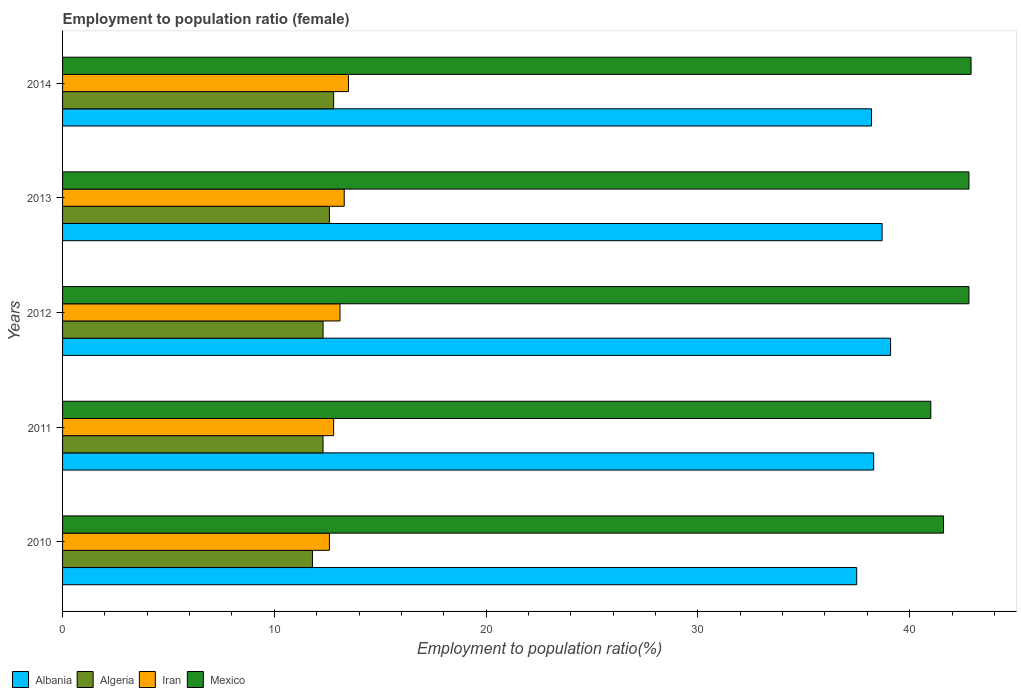How many groups of bars are there?
Give a very brief answer. 5. Are the number of bars per tick equal to the number of legend labels?
Offer a very short reply. Yes. What is the employment to population ratio in Mexico in 2010?
Provide a short and direct response. 41.6. Across all years, what is the maximum employment to population ratio in Algeria?
Your answer should be very brief. 12.8. Across all years, what is the minimum employment to population ratio in Algeria?
Provide a short and direct response. 11.8. What is the total employment to population ratio in Iran in the graph?
Provide a succinct answer. 65.3. What is the difference between the employment to population ratio in Algeria in 2012 and that in 2013?
Make the answer very short. -0.3. What is the difference between the employment to population ratio in Iran in 2011 and the employment to population ratio in Mexico in 2013?
Ensure brevity in your answer.  -30. What is the average employment to population ratio in Albania per year?
Keep it short and to the point. 38.36. In the year 2011, what is the difference between the employment to population ratio in Mexico and employment to population ratio in Algeria?
Offer a terse response. 28.7. What is the ratio of the employment to population ratio in Mexico in 2013 to that in 2014?
Make the answer very short. 1. Is the employment to population ratio in Albania in 2011 less than that in 2014?
Offer a terse response. No. Is the difference between the employment to population ratio in Mexico in 2011 and 2014 greater than the difference between the employment to population ratio in Algeria in 2011 and 2014?
Your answer should be compact. No. What is the difference between the highest and the second highest employment to population ratio in Albania?
Your answer should be compact. 0.4. In how many years, is the employment to population ratio in Albania greater than the average employment to population ratio in Albania taken over all years?
Your answer should be very brief. 2. What does the 4th bar from the top in 2014 represents?
Your response must be concise. Albania. What does the 2nd bar from the bottom in 2011 represents?
Your answer should be very brief. Algeria. What is the difference between two consecutive major ticks on the X-axis?
Provide a succinct answer. 10. Are the values on the major ticks of X-axis written in scientific E-notation?
Offer a terse response. No. Does the graph contain any zero values?
Keep it short and to the point. No. Does the graph contain grids?
Provide a short and direct response. No. Where does the legend appear in the graph?
Offer a very short reply. Bottom left. What is the title of the graph?
Give a very brief answer. Employment to population ratio (female). Does "Belarus" appear as one of the legend labels in the graph?
Your response must be concise. No. What is the label or title of the Y-axis?
Your answer should be very brief. Years. What is the Employment to population ratio(%) in Albania in 2010?
Your answer should be very brief. 37.5. What is the Employment to population ratio(%) of Algeria in 2010?
Provide a succinct answer. 11.8. What is the Employment to population ratio(%) in Iran in 2010?
Provide a succinct answer. 12.6. What is the Employment to population ratio(%) of Mexico in 2010?
Your answer should be very brief. 41.6. What is the Employment to population ratio(%) in Albania in 2011?
Provide a short and direct response. 38.3. What is the Employment to population ratio(%) of Algeria in 2011?
Provide a short and direct response. 12.3. What is the Employment to population ratio(%) of Iran in 2011?
Your answer should be very brief. 12.8. What is the Employment to population ratio(%) in Mexico in 2011?
Give a very brief answer. 41. What is the Employment to population ratio(%) in Albania in 2012?
Your answer should be very brief. 39.1. What is the Employment to population ratio(%) of Algeria in 2012?
Your answer should be very brief. 12.3. What is the Employment to population ratio(%) of Iran in 2012?
Your answer should be compact. 13.1. What is the Employment to population ratio(%) in Mexico in 2012?
Keep it short and to the point. 42.8. What is the Employment to population ratio(%) of Albania in 2013?
Offer a terse response. 38.7. What is the Employment to population ratio(%) of Algeria in 2013?
Make the answer very short. 12.6. What is the Employment to population ratio(%) in Iran in 2013?
Your answer should be compact. 13.3. What is the Employment to population ratio(%) in Mexico in 2013?
Provide a succinct answer. 42.8. What is the Employment to population ratio(%) in Albania in 2014?
Give a very brief answer. 38.2. What is the Employment to population ratio(%) in Algeria in 2014?
Make the answer very short. 12.8. What is the Employment to population ratio(%) in Mexico in 2014?
Provide a succinct answer. 42.9. Across all years, what is the maximum Employment to population ratio(%) in Albania?
Provide a succinct answer. 39.1. Across all years, what is the maximum Employment to population ratio(%) of Algeria?
Give a very brief answer. 12.8. Across all years, what is the maximum Employment to population ratio(%) in Mexico?
Offer a very short reply. 42.9. Across all years, what is the minimum Employment to population ratio(%) of Albania?
Provide a succinct answer. 37.5. Across all years, what is the minimum Employment to population ratio(%) in Algeria?
Ensure brevity in your answer.  11.8. Across all years, what is the minimum Employment to population ratio(%) of Iran?
Your answer should be very brief. 12.6. What is the total Employment to population ratio(%) of Albania in the graph?
Provide a succinct answer. 191.8. What is the total Employment to population ratio(%) in Algeria in the graph?
Ensure brevity in your answer.  61.8. What is the total Employment to population ratio(%) in Iran in the graph?
Provide a succinct answer. 65.3. What is the total Employment to population ratio(%) of Mexico in the graph?
Give a very brief answer. 211.1. What is the difference between the Employment to population ratio(%) in Albania in 2010 and that in 2011?
Your response must be concise. -0.8. What is the difference between the Employment to population ratio(%) of Algeria in 2010 and that in 2011?
Offer a terse response. -0.5. What is the difference between the Employment to population ratio(%) in Iran in 2010 and that in 2011?
Provide a succinct answer. -0.2. What is the difference between the Employment to population ratio(%) in Albania in 2010 and that in 2012?
Keep it short and to the point. -1.6. What is the difference between the Employment to population ratio(%) of Iran in 2010 and that in 2012?
Provide a succinct answer. -0.5. What is the difference between the Employment to population ratio(%) of Mexico in 2010 and that in 2012?
Offer a very short reply. -1.2. What is the difference between the Employment to population ratio(%) in Albania in 2010 and that in 2013?
Your answer should be compact. -1.2. What is the difference between the Employment to population ratio(%) of Iran in 2010 and that in 2013?
Offer a very short reply. -0.7. What is the difference between the Employment to population ratio(%) in Mexico in 2010 and that in 2013?
Keep it short and to the point. -1.2. What is the difference between the Employment to population ratio(%) in Iran in 2010 and that in 2014?
Offer a terse response. -0.9. What is the difference between the Employment to population ratio(%) of Algeria in 2011 and that in 2012?
Your answer should be very brief. 0. What is the difference between the Employment to population ratio(%) in Iran in 2011 and that in 2012?
Offer a very short reply. -0.3. What is the difference between the Employment to population ratio(%) of Algeria in 2011 and that in 2013?
Keep it short and to the point. -0.3. What is the difference between the Employment to population ratio(%) in Iran in 2011 and that in 2014?
Offer a very short reply. -0.7. What is the difference between the Employment to population ratio(%) of Mexico in 2011 and that in 2014?
Provide a short and direct response. -1.9. What is the difference between the Employment to population ratio(%) in Albania in 2012 and that in 2013?
Offer a terse response. 0.4. What is the difference between the Employment to population ratio(%) in Algeria in 2012 and that in 2013?
Provide a short and direct response. -0.3. What is the difference between the Employment to population ratio(%) in Iran in 2012 and that in 2013?
Make the answer very short. -0.2. What is the difference between the Employment to population ratio(%) in Mexico in 2012 and that in 2013?
Offer a terse response. 0. What is the difference between the Employment to population ratio(%) in Algeria in 2012 and that in 2014?
Your answer should be compact. -0.5. What is the difference between the Employment to population ratio(%) of Mexico in 2012 and that in 2014?
Offer a very short reply. -0.1. What is the difference between the Employment to population ratio(%) of Albania in 2013 and that in 2014?
Give a very brief answer. 0.5. What is the difference between the Employment to population ratio(%) of Iran in 2013 and that in 2014?
Provide a short and direct response. -0.2. What is the difference between the Employment to population ratio(%) in Mexico in 2013 and that in 2014?
Provide a short and direct response. -0.1. What is the difference between the Employment to population ratio(%) of Albania in 2010 and the Employment to population ratio(%) of Algeria in 2011?
Offer a very short reply. 25.2. What is the difference between the Employment to population ratio(%) of Albania in 2010 and the Employment to population ratio(%) of Iran in 2011?
Provide a succinct answer. 24.7. What is the difference between the Employment to population ratio(%) in Albania in 2010 and the Employment to population ratio(%) in Mexico in 2011?
Keep it short and to the point. -3.5. What is the difference between the Employment to population ratio(%) in Algeria in 2010 and the Employment to population ratio(%) in Mexico in 2011?
Give a very brief answer. -29.2. What is the difference between the Employment to population ratio(%) in Iran in 2010 and the Employment to population ratio(%) in Mexico in 2011?
Give a very brief answer. -28.4. What is the difference between the Employment to population ratio(%) in Albania in 2010 and the Employment to population ratio(%) in Algeria in 2012?
Make the answer very short. 25.2. What is the difference between the Employment to population ratio(%) in Albania in 2010 and the Employment to population ratio(%) in Iran in 2012?
Your answer should be compact. 24.4. What is the difference between the Employment to population ratio(%) of Albania in 2010 and the Employment to population ratio(%) of Mexico in 2012?
Ensure brevity in your answer.  -5.3. What is the difference between the Employment to population ratio(%) in Algeria in 2010 and the Employment to population ratio(%) in Iran in 2012?
Offer a terse response. -1.3. What is the difference between the Employment to population ratio(%) of Algeria in 2010 and the Employment to population ratio(%) of Mexico in 2012?
Offer a terse response. -31. What is the difference between the Employment to population ratio(%) in Iran in 2010 and the Employment to population ratio(%) in Mexico in 2012?
Make the answer very short. -30.2. What is the difference between the Employment to population ratio(%) in Albania in 2010 and the Employment to population ratio(%) in Algeria in 2013?
Provide a short and direct response. 24.9. What is the difference between the Employment to population ratio(%) in Albania in 2010 and the Employment to population ratio(%) in Iran in 2013?
Offer a very short reply. 24.2. What is the difference between the Employment to population ratio(%) of Albania in 2010 and the Employment to population ratio(%) of Mexico in 2013?
Make the answer very short. -5.3. What is the difference between the Employment to population ratio(%) in Algeria in 2010 and the Employment to population ratio(%) in Iran in 2013?
Provide a succinct answer. -1.5. What is the difference between the Employment to population ratio(%) in Algeria in 2010 and the Employment to population ratio(%) in Mexico in 2013?
Provide a succinct answer. -31. What is the difference between the Employment to population ratio(%) in Iran in 2010 and the Employment to population ratio(%) in Mexico in 2013?
Ensure brevity in your answer.  -30.2. What is the difference between the Employment to population ratio(%) of Albania in 2010 and the Employment to population ratio(%) of Algeria in 2014?
Offer a terse response. 24.7. What is the difference between the Employment to population ratio(%) of Algeria in 2010 and the Employment to population ratio(%) of Mexico in 2014?
Your answer should be compact. -31.1. What is the difference between the Employment to population ratio(%) of Iran in 2010 and the Employment to population ratio(%) of Mexico in 2014?
Provide a short and direct response. -30.3. What is the difference between the Employment to population ratio(%) of Albania in 2011 and the Employment to population ratio(%) of Iran in 2012?
Your answer should be very brief. 25.2. What is the difference between the Employment to population ratio(%) of Albania in 2011 and the Employment to population ratio(%) of Mexico in 2012?
Offer a terse response. -4.5. What is the difference between the Employment to population ratio(%) of Algeria in 2011 and the Employment to population ratio(%) of Mexico in 2012?
Make the answer very short. -30.5. What is the difference between the Employment to population ratio(%) of Albania in 2011 and the Employment to population ratio(%) of Algeria in 2013?
Make the answer very short. 25.7. What is the difference between the Employment to population ratio(%) of Albania in 2011 and the Employment to population ratio(%) of Iran in 2013?
Make the answer very short. 25. What is the difference between the Employment to population ratio(%) of Algeria in 2011 and the Employment to population ratio(%) of Iran in 2013?
Your answer should be very brief. -1. What is the difference between the Employment to population ratio(%) of Algeria in 2011 and the Employment to population ratio(%) of Mexico in 2013?
Offer a very short reply. -30.5. What is the difference between the Employment to population ratio(%) in Iran in 2011 and the Employment to population ratio(%) in Mexico in 2013?
Offer a terse response. -30. What is the difference between the Employment to population ratio(%) of Albania in 2011 and the Employment to population ratio(%) of Iran in 2014?
Your response must be concise. 24.8. What is the difference between the Employment to population ratio(%) in Algeria in 2011 and the Employment to population ratio(%) in Mexico in 2014?
Your answer should be compact. -30.6. What is the difference between the Employment to population ratio(%) in Iran in 2011 and the Employment to population ratio(%) in Mexico in 2014?
Your answer should be very brief. -30.1. What is the difference between the Employment to population ratio(%) of Albania in 2012 and the Employment to population ratio(%) of Algeria in 2013?
Your response must be concise. 26.5. What is the difference between the Employment to population ratio(%) of Albania in 2012 and the Employment to population ratio(%) of Iran in 2013?
Give a very brief answer. 25.8. What is the difference between the Employment to population ratio(%) in Albania in 2012 and the Employment to population ratio(%) in Mexico in 2013?
Give a very brief answer. -3.7. What is the difference between the Employment to population ratio(%) in Algeria in 2012 and the Employment to population ratio(%) in Mexico in 2013?
Provide a succinct answer. -30.5. What is the difference between the Employment to population ratio(%) of Iran in 2012 and the Employment to population ratio(%) of Mexico in 2013?
Make the answer very short. -29.7. What is the difference between the Employment to population ratio(%) in Albania in 2012 and the Employment to population ratio(%) in Algeria in 2014?
Provide a short and direct response. 26.3. What is the difference between the Employment to population ratio(%) in Albania in 2012 and the Employment to population ratio(%) in Iran in 2014?
Provide a succinct answer. 25.6. What is the difference between the Employment to population ratio(%) of Albania in 2012 and the Employment to population ratio(%) of Mexico in 2014?
Your answer should be very brief. -3.8. What is the difference between the Employment to population ratio(%) of Algeria in 2012 and the Employment to population ratio(%) of Mexico in 2014?
Keep it short and to the point. -30.6. What is the difference between the Employment to population ratio(%) of Iran in 2012 and the Employment to population ratio(%) of Mexico in 2014?
Offer a terse response. -29.8. What is the difference between the Employment to population ratio(%) in Albania in 2013 and the Employment to population ratio(%) in Algeria in 2014?
Provide a short and direct response. 25.9. What is the difference between the Employment to population ratio(%) in Albania in 2013 and the Employment to population ratio(%) in Iran in 2014?
Your answer should be very brief. 25.2. What is the difference between the Employment to population ratio(%) of Algeria in 2013 and the Employment to population ratio(%) of Iran in 2014?
Give a very brief answer. -0.9. What is the difference between the Employment to population ratio(%) in Algeria in 2013 and the Employment to population ratio(%) in Mexico in 2014?
Provide a short and direct response. -30.3. What is the difference between the Employment to population ratio(%) in Iran in 2013 and the Employment to population ratio(%) in Mexico in 2014?
Give a very brief answer. -29.6. What is the average Employment to population ratio(%) of Albania per year?
Offer a terse response. 38.36. What is the average Employment to population ratio(%) of Algeria per year?
Offer a very short reply. 12.36. What is the average Employment to population ratio(%) in Iran per year?
Make the answer very short. 13.06. What is the average Employment to population ratio(%) of Mexico per year?
Offer a very short reply. 42.22. In the year 2010, what is the difference between the Employment to population ratio(%) of Albania and Employment to population ratio(%) of Algeria?
Offer a terse response. 25.7. In the year 2010, what is the difference between the Employment to population ratio(%) of Albania and Employment to population ratio(%) of Iran?
Provide a short and direct response. 24.9. In the year 2010, what is the difference between the Employment to population ratio(%) of Algeria and Employment to population ratio(%) of Mexico?
Provide a short and direct response. -29.8. In the year 2010, what is the difference between the Employment to population ratio(%) of Iran and Employment to population ratio(%) of Mexico?
Offer a terse response. -29. In the year 2011, what is the difference between the Employment to population ratio(%) in Albania and Employment to population ratio(%) in Mexico?
Keep it short and to the point. -2.7. In the year 2011, what is the difference between the Employment to population ratio(%) in Algeria and Employment to population ratio(%) in Iran?
Your answer should be very brief. -0.5. In the year 2011, what is the difference between the Employment to population ratio(%) in Algeria and Employment to population ratio(%) in Mexico?
Your response must be concise. -28.7. In the year 2011, what is the difference between the Employment to population ratio(%) of Iran and Employment to population ratio(%) of Mexico?
Give a very brief answer. -28.2. In the year 2012, what is the difference between the Employment to population ratio(%) of Albania and Employment to population ratio(%) of Algeria?
Offer a very short reply. 26.8. In the year 2012, what is the difference between the Employment to population ratio(%) of Albania and Employment to population ratio(%) of Mexico?
Ensure brevity in your answer.  -3.7. In the year 2012, what is the difference between the Employment to population ratio(%) in Algeria and Employment to population ratio(%) in Mexico?
Provide a succinct answer. -30.5. In the year 2012, what is the difference between the Employment to population ratio(%) in Iran and Employment to population ratio(%) in Mexico?
Offer a terse response. -29.7. In the year 2013, what is the difference between the Employment to population ratio(%) in Albania and Employment to population ratio(%) in Algeria?
Offer a terse response. 26.1. In the year 2013, what is the difference between the Employment to population ratio(%) of Albania and Employment to population ratio(%) of Iran?
Make the answer very short. 25.4. In the year 2013, what is the difference between the Employment to population ratio(%) in Algeria and Employment to population ratio(%) in Iran?
Give a very brief answer. -0.7. In the year 2013, what is the difference between the Employment to population ratio(%) of Algeria and Employment to population ratio(%) of Mexico?
Offer a very short reply. -30.2. In the year 2013, what is the difference between the Employment to population ratio(%) of Iran and Employment to population ratio(%) of Mexico?
Provide a short and direct response. -29.5. In the year 2014, what is the difference between the Employment to population ratio(%) of Albania and Employment to population ratio(%) of Algeria?
Keep it short and to the point. 25.4. In the year 2014, what is the difference between the Employment to population ratio(%) of Albania and Employment to population ratio(%) of Iran?
Your response must be concise. 24.7. In the year 2014, what is the difference between the Employment to population ratio(%) of Albania and Employment to population ratio(%) of Mexico?
Offer a very short reply. -4.7. In the year 2014, what is the difference between the Employment to population ratio(%) of Algeria and Employment to population ratio(%) of Mexico?
Your response must be concise. -30.1. In the year 2014, what is the difference between the Employment to population ratio(%) in Iran and Employment to population ratio(%) in Mexico?
Your answer should be compact. -29.4. What is the ratio of the Employment to population ratio(%) in Albania in 2010 to that in 2011?
Your answer should be compact. 0.98. What is the ratio of the Employment to population ratio(%) of Algeria in 2010 to that in 2011?
Make the answer very short. 0.96. What is the ratio of the Employment to population ratio(%) in Iran in 2010 to that in 2011?
Offer a terse response. 0.98. What is the ratio of the Employment to population ratio(%) in Mexico in 2010 to that in 2011?
Give a very brief answer. 1.01. What is the ratio of the Employment to population ratio(%) in Albania in 2010 to that in 2012?
Your answer should be very brief. 0.96. What is the ratio of the Employment to population ratio(%) in Algeria in 2010 to that in 2012?
Your answer should be compact. 0.96. What is the ratio of the Employment to population ratio(%) in Iran in 2010 to that in 2012?
Provide a short and direct response. 0.96. What is the ratio of the Employment to population ratio(%) of Mexico in 2010 to that in 2012?
Offer a very short reply. 0.97. What is the ratio of the Employment to population ratio(%) in Algeria in 2010 to that in 2013?
Provide a short and direct response. 0.94. What is the ratio of the Employment to population ratio(%) of Mexico in 2010 to that in 2013?
Offer a very short reply. 0.97. What is the ratio of the Employment to population ratio(%) of Albania in 2010 to that in 2014?
Offer a terse response. 0.98. What is the ratio of the Employment to population ratio(%) in Algeria in 2010 to that in 2014?
Make the answer very short. 0.92. What is the ratio of the Employment to population ratio(%) in Iran in 2010 to that in 2014?
Provide a succinct answer. 0.93. What is the ratio of the Employment to population ratio(%) of Mexico in 2010 to that in 2014?
Your answer should be very brief. 0.97. What is the ratio of the Employment to population ratio(%) in Albania in 2011 to that in 2012?
Your answer should be very brief. 0.98. What is the ratio of the Employment to population ratio(%) in Iran in 2011 to that in 2012?
Provide a succinct answer. 0.98. What is the ratio of the Employment to population ratio(%) in Mexico in 2011 to that in 2012?
Give a very brief answer. 0.96. What is the ratio of the Employment to population ratio(%) in Algeria in 2011 to that in 2013?
Provide a succinct answer. 0.98. What is the ratio of the Employment to population ratio(%) of Iran in 2011 to that in 2013?
Keep it short and to the point. 0.96. What is the ratio of the Employment to population ratio(%) of Mexico in 2011 to that in 2013?
Your response must be concise. 0.96. What is the ratio of the Employment to population ratio(%) of Albania in 2011 to that in 2014?
Your answer should be compact. 1. What is the ratio of the Employment to population ratio(%) in Algeria in 2011 to that in 2014?
Make the answer very short. 0.96. What is the ratio of the Employment to population ratio(%) in Iran in 2011 to that in 2014?
Your answer should be very brief. 0.95. What is the ratio of the Employment to population ratio(%) in Mexico in 2011 to that in 2014?
Keep it short and to the point. 0.96. What is the ratio of the Employment to population ratio(%) in Albania in 2012 to that in 2013?
Offer a terse response. 1.01. What is the ratio of the Employment to population ratio(%) in Algeria in 2012 to that in 2013?
Offer a very short reply. 0.98. What is the ratio of the Employment to population ratio(%) in Albania in 2012 to that in 2014?
Keep it short and to the point. 1.02. What is the ratio of the Employment to population ratio(%) of Algeria in 2012 to that in 2014?
Keep it short and to the point. 0.96. What is the ratio of the Employment to population ratio(%) of Iran in 2012 to that in 2014?
Offer a very short reply. 0.97. What is the ratio of the Employment to population ratio(%) of Albania in 2013 to that in 2014?
Give a very brief answer. 1.01. What is the ratio of the Employment to population ratio(%) of Algeria in 2013 to that in 2014?
Provide a succinct answer. 0.98. What is the ratio of the Employment to population ratio(%) in Iran in 2013 to that in 2014?
Offer a terse response. 0.99. What is the difference between the highest and the second highest Employment to population ratio(%) of Algeria?
Provide a succinct answer. 0.2. What is the difference between the highest and the second highest Employment to population ratio(%) of Iran?
Make the answer very short. 0.2. What is the difference between the highest and the second highest Employment to population ratio(%) in Mexico?
Keep it short and to the point. 0.1. What is the difference between the highest and the lowest Employment to population ratio(%) of Albania?
Make the answer very short. 1.6. What is the difference between the highest and the lowest Employment to population ratio(%) of Iran?
Your response must be concise. 0.9. 